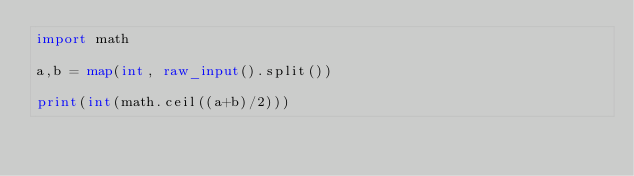Convert code to text. <code><loc_0><loc_0><loc_500><loc_500><_Python_>import math

a,b = map(int, raw_input().split())

print(int(math.ceil((a+b)/2)))</code> 